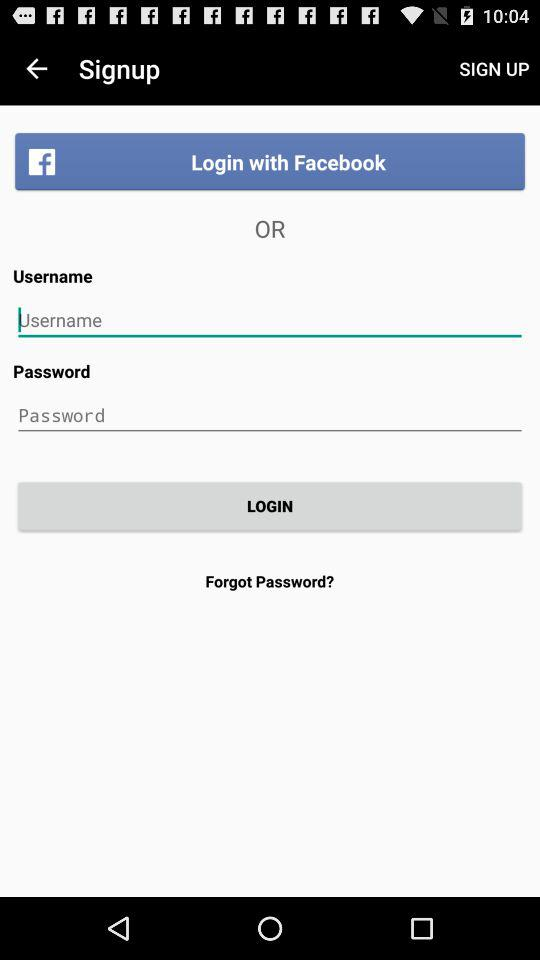How can we log in? You can log in with "Facebook" or "Username". 